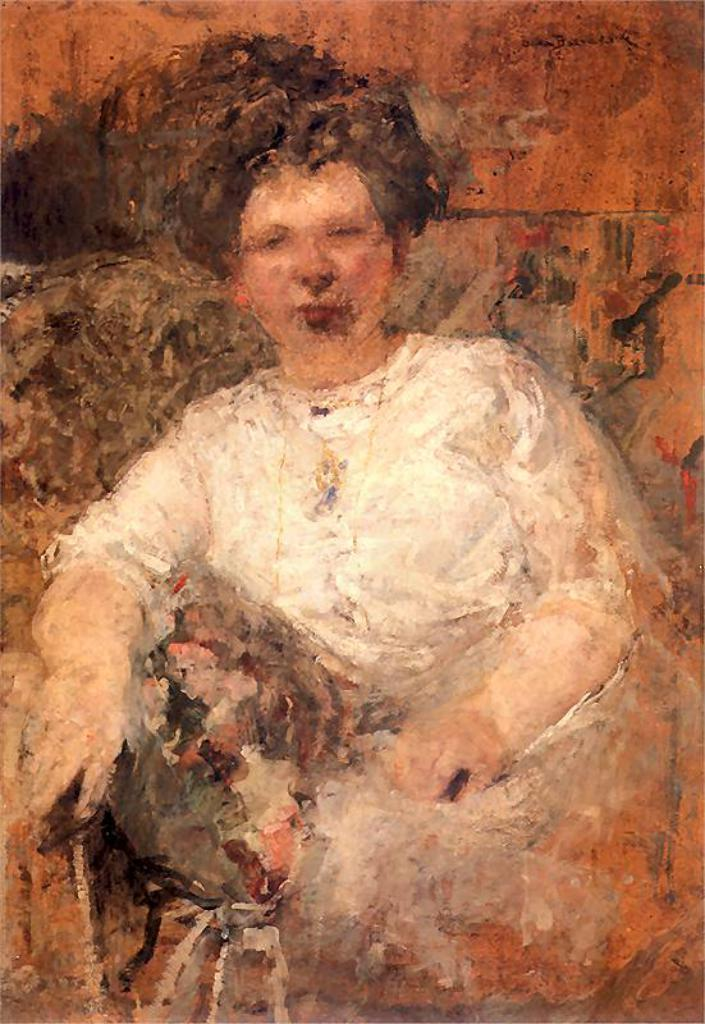What is depicted in the image? The image contains a painting of a woman. What is the woman in the painting wearing? The woman in the painting is wearing a white dress. What colors can be seen in the painting? The painting has colors including white, orange, black, cream, and brown. How many apples are on the woman's head in the painting? There are no apples present in the painting; it features a woman wearing a white dress. What type of underwear is the woman wearing in the painting? The painting does not depict the woman's underwear, as it focuses on her white dress. 